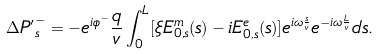Convert formula to latex. <formula><loc_0><loc_0><loc_500><loc_500>\Delta { P ^ { \prime } } _ { s } ^ { - } = - e ^ { i \phi ^ { - } } \frac { q } { v } \int _ { 0 } ^ { L } [ \xi E ^ { m } _ { 0 , s } ( s ) - i E ^ { e } _ { 0 , s } ( s ) ] e ^ { i \omega \frac { s } { v } } e ^ { - i \omega \frac { L } { v } } d s .</formula> 